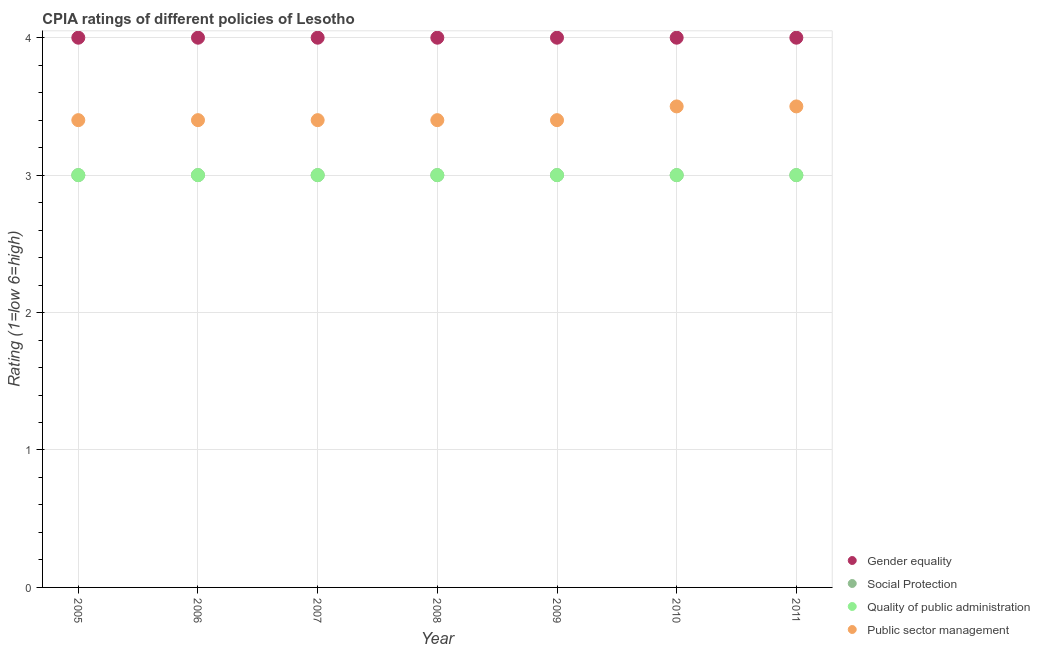Is the number of dotlines equal to the number of legend labels?
Your answer should be compact. Yes. What is the cpia rating of gender equality in 2005?
Provide a succinct answer. 4. Across all years, what is the maximum cpia rating of gender equality?
Provide a short and direct response. 4. Across all years, what is the minimum cpia rating of social protection?
Offer a very short reply. 3. What is the total cpia rating of social protection in the graph?
Offer a very short reply. 21. What is the difference between the cpia rating of social protection in 2011 and the cpia rating of quality of public administration in 2006?
Ensure brevity in your answer.  0. What is the average cpia rating of gender equality per year?
Offer a terse response. 4. What is the ratio of the cpia rating of quality of public administration in 2009 to that in 2010?
Ensure brevity in your answer.  1. Is the cpia rating of public sector management in 2009 less than that in 2010?
Your answer should be compact. Yes. In how many years, is the cpia rating of social protection greater than the average cpia rating of social protection taken over all years?
Give a very brief answer. 0. Is it the case that in every year, the sum of the cpia rating of public sector management and cpia rating of social protection is greater than the sum of cpia rating of gender equality and cpia rating of quality of public administration?
Give a very brief answer. Yes. Is it the case that in every year, the sum of the cpia rating of gender equality and cpia rating of social protection is greater than the cpia rating of quality of public administration?
Offer a terse response. Yes. Is the cpia rating of public sector management strictly less than the cpia rating of gender equality over the years?
Your response must be concise. Yes. How many dotlines are there?
Ensure brevity in your answer.  4. What is the difference between two consecutive major ticks on the Y-axis?
Offer a terse response. 1. Are the values on the major ticks of Y-axis written in scientific E-notation?
Ensure brevity in your answer.  No. Where does the legend appear in the graph?
Ensure brevity in your answer.  Bottom right. How many legend labels are there?
Make the answer very short. 4. What is the title of the graph?
Offer a very short reply. CPIA ratings of different policies of Lesotho. Does "Taxes on revenue" appear as one of the legend labels in the graph?
Your answer should be very brief. No. What is the Rating (1=low 6=high) in Gender equality in 2005?
Give a very brief answer. 4. What is the Rating (1=low 6=high) of Quality of public administration in 2005?
Provide a succinct answer. 3. What is the Rating (1=low 6=high) of Social Protection in 2006?
Offer a very short reply. 3. What is the Rating (1=low 6=high) in Public sector management in 2006?
Offer a terse response. 3.4. What is the Rating (1=low 6=high) in Gender equality in 2007?
Offer a very short reply. 4. What is the Rating (1=low 6=high) in Quality of public administration in 2007?
Your answer should be compact. 3. What is the Rating (1=low 6=high) of Public sector management in 2007?
Your answer should be compact. 3.4. What is the Rating (1=low 6=high) in Gender equality in 2008?
Your answer should be very brief. 4. What is the Rating (1=low 6=high) in Public sector management in 2008?
Your answer should be compact. 3.4. What is the Rating (1=low 6=high) in Gender equality in 2009?
Your answer should be very brief. 4. What is the Rating (1=low 6=high) of Quality of public administration in 2009?
Ensure brevity in your answer.  3. What is the Rating (1=low 6=high) in Social Protection in 2010?
Offer a terse response. 3. What is the Rating (1=low 6=high) in Quality of public administration in 2010?
Your response must be concise. 3. What is the Rating (1=low 6=high) of Quality of public administration in 2011?
Your answer should be very brief. 3. What is the Rating (1=low 6=high) of Public sector management in 2011?
Your response must be concise. 3.5. Across all years, what is the maximum Rating (1=low 6=high) in Quality of public administration?
Offer a terse response. 3. Across all years, what is the minimum Rating (1=low 6=high) of Social Protection?
Provide a short and direct response. 3. Across all years, what is the minimum Rating (1=low 6=high) in Quality of public administration?
Make the answer very short. 3. What is the total Rating (1=low 6=high) of Social Protection in the graph?
Make the answer very short. 21. What is the total Rating (1=low 6=high) of Public sector management in the graph?
Your answer should be compact. 24. What is the difference between the Rating (1=low 6=high) in Social Protection in 2005 and that in 2006?
Keep it short and to the point. 0. What is the difference between the Rating (1=low 6=high) of Public sector management in 2005 and that in 2006?
Ensure brevity in your answer.  0. What is the difference between the Rating (1=low 6=high) of Gender equality in 2005 and that in 2007?
Your answer should be compact. 0. What is the difference between the Rating (1=low 6=high) in Social Protection in 2005 and that in 2007?
Your answer should be very brief. 0. What is the difference between the Rating (1=low 6=high) of Quality of public administration in 2005 and that in 2007?
Make the answer very short. 0. What is the difference between the Rating (1=low 6=high) of Public sector management in 2005 and that in 2007?
Make the answer very short. 0. What is the difference between the Rating (1=low 6=high) in Gender equality in 2005 and that in 2008?
Offer a very short reply. 0. What is the difference between the Rating (1=low 6=high) of Quality of public administration in 2005 and that in 2008?
Offer a terse response. 0. What is the difference between the Rating (1=low 6=high) of Quality of public administration in 2005 and that in 2009?
Give a very brief answer. 0. What is the difference between the Rating (1=low 6=high) in Social Protection in 2005 and that in 2010?
Keep it short and to the point. 0. What is the difference between the Rating (1=low 6=high) in Quality of public administration in 2005 and that in 2010?
Your response must be concise. 0. What is the difference between the Rating (1=low 6=high) of Quality of public administration in 2005 and that in 2011?
Provide a short and direct response. 0. What is the difference between the Rating (1=low 6=high) in Social Protection in 2006 and that in 2008?
Your response must be concise. 0. What is the difference between the Rating (1=low 6=high) of Social Protection in 2006 and that in 2009?
Offer a very short reply. 0. What is the difference between the Rating (1=low 6=high) in Public sector management in 2006 and that in 2009?
Offer a very short reply. 0. What is the difference between the Rating (1=low 6=high) in Gender equality in 2006 and that in 2010?
Provide a short and direct response. 0. What is the difference between the Rating (1=low 6=high) of Public sector management in 2006 and that in 2010?
Your response must be concise. -0.1. What is the difference between the Rating (1=low 6=high) of Social Protection in 2007 and that in 2008?
Offer a terse response. 0. What is the difference between the Rating (1=low 6=high) in Quality of public administration in 2007 and that in 2008?
Your answer should be compact. 0. What is the difference between the Rating (1=low 6=high) of Public sector management in 2007 and that in 2008?
Offer a very short reply. 0. What is the difference between the Rating (1=low 6=high) of Gender equality in 2007 and that in 2009?
Give a very brief answer. 0. What is the difference between the Rating (1=low 6=high) in Public sector management in 2007 and that in 2009?
Ensure brevity in your answer.  0. What is the difference between the Rating (1=low 6=high) of Gender equality in 2007 and that in 2010?
Offer a very short reply. 0. What is the difference between the Rating (1=low 6=high) of Quality of public administration in 2007 and that in 2010?
Your answer should be very brief. 0. What is the difference between the Rating (1=low 6=high) in Gender equality in 2007 and that in 2011?
Your answer should be very brief. 0. What is the difference between the Rating (1=low 6=high) in Quality of public administration in 2007 and that in 2011?
Ensure brevity in your answer.  0. What is the difference between the Rating (1=low 6=high) of Social Protection in 2008 and that in 2009?
Ensure brevity in your answer.  0. What is the difference between the Rating (1=low 6=high) of Quality of public administration in 2008 and that in 2009?
Your answer should be compact. 0. What is the difference between the Rating (1=low 6=high) in Public sector management in 2008 and that in 2009?
Your answer should be compact. 0. What is the difference between the Rating (1=low 6=high) of Gender equality in 2008 and that in 2010?
Give a very brief answer. 0. What is the difference between the Rating (1=low 6=high) in Quality of public administration in 2008 and that in 2010?
Your response must be concise. 0. What is the difference between the Rating (1=low 6=high) of Public sector management in 2008 and that in 2010?
Give a very brief answer. -0.1. What is the difference between the Rating (1=low 6=high) in Gender equality in 2008 and that in 2011?
Give a very brief answer. 0. What is the difference between the Rating (1=low 6=high) of Quality of public administration in 2008 and that in 2011?
Make the answer very short. 0. What is the difference between the Rating (1=low 6=high) in Public sector management in 2008 and that in 2011?
Offer a very short reply. -0.1. What is the difference between the Rating (1=low 6=high) of Gender equality in 2009 and that in 2010?
Ensure brevity in your answer.  0. What is the difference between the Rating (1=low 6=high) of Social Protection in 2009 and that in 2010?
Give a very brief answer. 0. What is the difference between the Rating (1=low 6=high) in Gender equality in 2009 and that in 2011?
Keep it short and to the point. 0. What is the difference between the Rating (1=low 6=high) of Quality of public administration in 2009 and that in 2011?
Offer a terse response. 0. What is the difference between the Rating (1=low 6=high) in Gender equality in 2010 and that in 2011?
Ensure brevity in your answer.  0. What is the difference between the Rating (1=low 6=high) in Quality of public administration in 2010 and that in 2011?
Offer a terse response. 0. What is the difference between the Rating (1=low 6=high) of Gender equality in 2005 and the Rating (1=low 6=high) of Public sector management in 2006?
Your answer should be very brief. 0.6. What is the difference between the Rating (1=low 6=high) of Social Protection in 2005 and the Rating (1=low 6=high) of Public sector management in 2006?
Give a very brief answer. -0.4. What is the difference between the Rating (1=low 6=high) of Quality of public administration in 2005 and the Rating (1=low 6=high) of Public sector management in 2006?
Provide a short and direct response. -0.4. What is the difference between the Rating (1=low 6=high) of Social Protection in 2005 and the Rating (1=low 6=high) of Quality of public administration in 2007?
Provide a succinct answer. 0. What is the difference between the Rating (1=low 6=high) of Social Protection in 2005 and the Rating (1=low 6=high) of Public sector management in 2007?
Your answer should be compact. -0.4. What is the difference between the Rating (1=low 6=high) of Quality of public administration in 2005 and the Rating (1=low 6=high) of Public sector management in 2007?
Your answer should be very brief. -0.4. What is the difference between the Rating (1=low 6=high) in Gender equality in 2005 and the Rating (1=low 6=high) in Social Protection in 2008?
Make the answer very short. 1. What is the difference between the Rating (1=low 6=high) of Gender equality in 2005 and the Rating (1=low 6=high) of Quality of public administration in 2008?
Keep it short and to the point. 1. What is the difference between the Rating (1=low 6=high) of Gender equality in 2005 and the Rating (1=low 6=high) of Public sector management in 2008?
Provide a short and direct response. 0.6. What is the difference between the Rating (1=low 6=high) of Social Protection in 2005 and the Rating (1=low 6=high) of Quality of public administration in 2008?
Keep it short and to the point. 0. What is the difference between the Rating (1=low 6=high) in Gender equality in 2005 and the Rating (1=low 6=high) in Quality of public administration in 2009?
Make the answer very short. 1. What is the difference between the Rating (1=low 6=high) of Social Protection in 2005 and the Rating (1=low 6=high) of Quality of public administration in 2009?
Provide a succinct answer. 0. What is the difference between the Rating (1=low 6=high) in Social Protection in 2005 and the Rating (1=low 6=high) in Public sector management in 2009?
Your answer should be compact. -0.4. What is the difference between the Rating (1=low 6=high) in Gender equality in 2005 and the Rating (1=low 6=high) in Quality of public administration in 2010?
Ensure brevity in your answer.  1. What is the difference between the Rating (1=low 6=high) of Gender equality in 2005 and the Rating (1=low 6=high) of Public sector management in 2010?
Offer a very short reply. 0.5. What is the difference between the Rating (1=low 6=high) of Social Protection in 2005 and the Rating (1=low 6=high) of Quality of public administration in 2010?
Your answer should be very brief. 0. What is the difference between the Rating (1=low 6=high) in Social Protection in 2005 and the Rating (1=low 6=high) in Public sector management in 2010?
Provide a succinct answer. -0.5. What is the difference between the Rating (1=low 6=high) of Quality of public administration in 2005 and the Rating (1=low 6=high) of Public sector management in 2010?
Your response must be concise. -0.5. What is the difference between the Rating (1=low 6=high) in Gender equality in 2005 and the Rating (1=low 6=high) in Public sector management in 2011?
Keep it short and to the point. 0.5. What is the difference between the Rating (1=low 6=high) of Social Protection in 2005 and the Rating (1=low 6=high) of Quality of public administration in 2011?
Offer a very short reply. 0. What is the difference between the Rating (1=low 6=high) in Gender equality in 2006 and the Rating (1=low 6=high) in Quality of public administration in 2007?
Offer a terse response. 1. What is the difference between the Rating (1=low 6=high) of Social Protection in 2006 and the Rating (1=low 6=high) of Quality of public administration in 2007?
Provide a succinct answer. 0. What is the difference between the Rating (1=low 6=high) in Quality of public administration in 2006 and the Rating (1=low 6=high) in Public sector management in 2007?
Offer a terse response. -0.4. What is the difference between the Rating (1=low 6=high) of Gender equality in 2006 and the Rating (1=low 6=high) of Social Protection in 2008?
Offer a very short reply. 1. What is the difference between the Rating (1=low 6=high) in Gender equality in 2006 and the Rating (1=low 6=high) in Quality of public administration in 2008?
Make the answer very short. 1. What is the difference between the Rating (1=low 6=high) of Gender equality in 2006 and the Rating (1=low 6=high) of Public sector management in 2008?
Give a very brief answer. 0.6. What is the difference between the Rating (1=low 6=high) in Social Protection in 2006 and the Rating (1=low 6=high) in Public sector management in 2008?
Provide a short and direct response. -0.4. What is the difference between the Rating (1=low 6=high) of Quality of public administration in 2006 and the Rating (1=low 6=high) of Public sector management in 2008?
Make the answer very short. -0.4. What is the difference between the Rating (1=low 6=high) in Gender equality in 2006 and the Rating (1=low 6=high) in Social Protection in 2009?
Your response must be concise. 1. What is the difference between the Rating (1=low 6=high) of Gender equality in 2006 and the Rating (1=low 6=high) of Quality of public administration in 2009?
Provide a short and direct response. 1. What is the difference between the Rating (1=low 6=high) in Gender equality in 2006 and the Rating (1=low 6=high) in Public sector management in 2009?
Provide a succinct answer. 0.6. What is the difference between the Rating (1=low 6=high) of Social Protection in 2006 and the Rating (1=low 6=high) of Quality of public administration in 2009?
Offer a terse response. 0. What is the difference between the Rating (1=low 6=high) of Gender equality in 2006 and the Rating (1=low 6=high) of Public sector management in 2010?
Your answer should be compact. 0.5. What is the difference between the Rating (1=low 6=high) of Social Protection in 2006 and the Rating (1=low 6=high) of Public sector management in 2010?
Make the answer very short. -0.5. What is the difference between the Rating (1=low 6=high) of Gender equality in 2006 and the Rating (1=low 6=high) of Social Protection in 2011?
Keep it short and to the point. 1. What is the difference between the Rating (1=low 6=high) in Gender equality in 2006 and the Rating (1=low 6=high) in Quality of public administration in 2011?
Keep it short and to the point. 1. What is the difference between the Rating (1=low 6=high) in Social Protection in 2006 and the Rating (1=low 6=high) in Quality of public administration in 2011?
Give a very brief answer. 0. What is the difference between the Rating (1=low 6=high) in Quality of public administration in 2006 and the Rating (1=low 6=high) in Public sector management in 2011?
Provide a short and direct response. -0.5. What is the difference between the Rating (1=low 6=high) in Gender equality in 2007 and the Rating (1=low 6=high) in Social Protection in 2008?
Offer a very short reply. 1. What is the difference between the Rating (1=low 6=high) in Gender equality in 2007 and the Rating (1=low 6=high) in Public sector management in 2008?
Your answer should be very brief. 0.6. What is the difference between the Rating (1=low 6=high) in Gender equality in 2007 and the Rating (1=low 6=high) in Quality of public administration in 2009?
Make the answer very short. 1. What is the difference between the Rating (1=low 6=high) of Social Protection in 2007 and the Rating (1=low 6=high) of Quality of public administration in 2009?
Offer a very short reply. 0. What is the difference between the Rating (1=low 6=high) of Social Protection in 2007 and the Rating (1=low 6=high) of Public sector management in 2009?
Offer a very short reply. -0.4. What is the difference between the Rating (1=low 6=high) of Gender equality in 2007 and the Rating (1=low 6=high) of Social Protection in 2010?
Offer a terse response. 1. What is the difference between the Rating (1=low 6=high) in Gender equality in 2007 and the Rating (1=low 6=high) in Quality of public administration in 2010?
Your answer should be very brief. 1. What is the difference between the Rating (1=low 6=high) in Gender equality in 2007 and the Rating (1=low 6=high) in Public sector management in 2010?
Make the answer very short. 0.5. What is the difference between the Rating (1=low 6=high) of Social Protection in 2007 and the Rating (1=low 6=high) of Quality of public administration in 2010?
Provide a succinct answer. 0. What is the difference between the Rating (1=low 6=high) of Gender equality in 2007 and the Rating (1=low 6=high) of Quality of public administration in 2011?
Keep it short and to the point. 1. What is the difference between the Rating (1=low 6=high) of Social Protection in 2007 and the Rating (1=low 6=high) of Quality of public administration in 2011?
Provide a short and direct response. 0. What is the difference between the Rating (1=low 6=high) of Gender equality in 2008 and the Rating (1=low 6=high) of Quality of public administration in 2009?
Provide a short and direct response. 1. What is the difference between the Rating (1=low 6=high) in Gender equality in 2008 and the Rating (1=low 6=high) in Quality of public administration in 2010?
Offer a terse response. 1. What is the difference between the Rating (1=low 6=high) in Gender equality in 2008 and the Rating (1=low 6=high) in Public sector management in 2010?
Keep it short and to the point. 0.5. What is the difference between the Rating (1=low 6=high) in Social Protection in 2008 and the Rating (1=low 6=high) in Quality of public administration in 2010?
Provide a succinct answer. 0. What is the difference between the Rating (1=low 6=high) in Social Protection in 2008 and the Rating (1=low 6=high) in Public sector management in 2010?
Your answer should be very brief. -0.5. What is the difference between the Rating (1=low 6=high) in Quality of public administration in 2008 and the Rating (1=low 6=high) in Public sector management in 2010?
Ensure brevity in your answer.  -0.5. What is the difference between the Rating (1=low 6=high) of Gender equality in 2008 and the Rating (1=low 6=high) of Public sector management in 2011?
Offer a terse response. 0.5. What is the difference between the Rating (1=low 6=high) in Quality of public administration in 2008 and the Rating (1=low 6=high) in Public sector management in 2011?
Keep it short and to the point. -0.5. What is the difference between the Rating (1=low 6=high) in Gender equality in 2009 and the Rating (1=low 6=high) in Quality of public administration in 2010?
Your answer should be compact. 1. What is the difference between the Rating (1=low 6=high) in Social Protection in 2009 and the Rating (1=low 6=high) in Quality of public administration in 2010?
Provide a succinct answer. 0. What is the difference between the Rating (1=low 6=high) in Quality of public administration in 2009 and the Rating (1=low 6=high) in Public sector management in 2010?
Ensure brevity in your answer.  -0.5. What is the difference between the Rating (1=low 6=high) in Gender equality in 2009 and the Rating (1=low 6=high) in Social Protection in 2011?
Provide a short and direct response. 1. What is the difference between the Rating (1=low 6=high) of Gender equality in 2009 and the Rating (1=low 6=high) of Public sector management in 2011?
Give a very brief answer. 0.5. What is the difference between the Rating (1=low 6=high) in Social Protection in 2009 and the Rating (1=low 6=high) in Quality of public administration in 2011?
Give a very brief answer. 0. What is the difference between the Rating (1=low 6=high) of Social Protection in 2009 and the Rating (1=low 6=high) of Public sector management in 2011?
Offer a terse response. -0.5. What is the difference between the Rating (1=low 6=high) of Gender equality in 2010 and the Rating (1=low 6=high) of Public sector management in 2011?
Offer a terse response. 0.5. What is the difference between the Rating (1=low 6=high) of Social Protection in 2010 and the Rating (1=low 6=high) of Quality of public administration in 2011?
Make the answer very short. 0. What is the average Rating (1=low 6=high) in Gender equality per year?
Offer a very short reply. 4. What is the average Rating (1=low 6=high) in Social Protection per year?
Your answer should be very brief. 3. What is the average Rating (1=low 6=high) in Quality of public administration per year?
Keep it short and to the point. 3. What is the average Rating (1=low 6=high) in Public sector management per year?
Your answer should be compact. 3.43. In the year 2005, what is the difference between the Rating (1=low 6=high) in Gender equality and Rating (1=low 6=high) in Social Protection?
Offer a very short reply. 1. In the year 2006, what is the difference between the Rating (1=low 6=high) of Gender equality and Rating (1=low 6=high) of Quality of public administration?
Provide a succinct answer. 1. In the year 2006, what is the difference between the Rating (1=low 6=high) in Gender equality and Rating (1=low 6=high) in Public sector management?
Keep it short and to the point. 0.6. In the year 2006, what is the difference between the Rating (1=low 6=high) of Social Protection and Rating (1=low 6=high) of Quality of public administration?
Provide a succinct answer. 0. In the year 2006, what is the difference between the Rating (1=low 6=high) of Social Protection and Rating (1=low 6=high) of Public sector management?
Provide a short and direct response. -0.4. In the year 2008, what is the difference between the Rating (1=low 6=high) in Gender equality and Rating (1=low 6=high) in Social Protection?
Give a very brief answer. 1. In the year 2008, what is the difference between the Rating (1=low 6=high) in Gender equality and Rating (1=low 6=high) in Quality of public administration?
Provide a short and direct response. 1. In the year 2008, what is the difference between the Rating (1=low 6=high) of Social Protection and Rating (1=low 6=high) of Public sector management?
Ensure brevity in your answer.  -0.4. In the year 2008, what is the difference between the Rating (1=low 6=high) in Quality of public administration and Rating (1=low 6=high) in Public sector management?
Provide a short and direct response. -0.4. In the year 2009, what is the difference between the Rating (1=low 6=high) of Gender equality and Rating (1=low 6=high) of Social Protection?
Give a very brief answer. 1. In the year 2009, what is the difference between the Rating (1=low 6=high) in Gender equality and Rating (1=low 6=high) in Quality of public administration?
Offer a very short reply. 1. In the year 2009, what is the difference between the Rating (1=low 6=high) of Gender equality and Rating (1=low 6=high) of Public sector management?
Your response must be concise. 0.6. In the year 2009, what is the difference between the Rating (1=low 6=high) in Social Protection and Rating (1=low 6=high) in Public sector management?
Give a very brief answer. -0.4. In the year 2010, what is the difference between the Rating (1=low 6=high) in Gender equality and Rating (1=low 6=high) in Quality of public administration?
Keep it short and to the point. 1. In the year 2010, what is the difference between the Rating (1=low 6=high) in Social Protection and Rating (1=low 6=high) in Quality of public administration?
Offer a very short reply. 0. In the year 2010, what is the difference between the Rating (1=low 6=high) in Quality of public administration and Rating (1=low 6=high) in Public sector management?
Your response must be concise. -0.5. In the year 2011, what is the difference between the Rating (1=low 6=high) of Gender equality and Rating (1=low 6=high) of Public sector management?
Provide a succinct answer. 0.5. In the year 2011, what is the difference between the Rating (1=low 6=high) of Social Protection and Rating (1=low 6=high) of Quality of public administration?
Your response must be concise. 0. In the year 2011, what is the difference between the Rating (1=low 6=high) in Quality of public administration and Rating (1=low 6=high) in Public sector management?
Your response must be concise. -0.5. What is the ratio of the Rating (1=low 6=high) of Social Protection in 2005 to that in 2006?
Provide a short and direct response. 1. What is the ratio of the Rating (1=low 6=high) in Gender equality in 2005 to that in 2007?
Give a very brief answer. 1. What is the ratio of the Rating (1=low 6=high) of Gender equality in 2005 to that in 2008?
Offer a very short reply. 1. What is the ratio of the Rating (1=low 6=high) in Social Protection in 2005 to that in 2008?
Ensure brevity in your answer.  1. What is the ratio of the Rating (1=low 6=high) in Quality of public administration in 2005 to that in 2008?
Ensure brevity in your answer.  1. What is the ratio of the Rating (1=low 6=high) of Social Protection in 2005 to that in 2009?
Offer a very short reply. 1. What is the ratio of the Rating (1=low 6=high) in Quality of public administration in 2005 to that in 2009?
Give a very brief answer. 1. What is the ratio of the Rating (1=low 6=high) in Quality of public administration in 2005 to that in 2010?
Ensure brevity in your answer.  1. What is the ratio of the Rating (1=low 6=high) of Public sector management in 2005 to that in 2010?
Your response must be concise. 0.97. What is the ratio of the Rating (1=low 6=high) of Gender equality in 2005 to that in 2011?
Offer a very short reply. 1. What is the ratio of the Rating (1=low 6=high) of Public sector management in 2005 to that in 2011?
Offer a very short reply. 0.97. What is the ratio of the Rating (1=low 6=high) of Social Protection in 2006 to that in 2007?
Your answer should be compact. 1. What is the ratio of the Rating (1=low 6=high) of Social Protection in 2006 to that in 2008?
Keep it short and to the point. 1. What is the ratio of the Rating (1=low 6=high) of Quality of public administration in 2006 to that in 2008?
Provide a short and direct response. 1. What is the ratio of the Rating (1=low 6=high) of Public sector management in 2006 to that in 2008?
Keep it short and to the point. 1. What is the ratio of the Rating (1=low 6=high) in Social Protection in 2006 to that in 2009?
Keep it short and to the point. 1. What is the ratio of the Rating (1=low 6=high) in Quality of public administration in 2006 to that in 2009?
Offer a terse response. 1. What is the ratio of the Rating (1=low 6=high) in Gender equality in 2006 to that in 2010?
Make the answer very short. 1. What is the ratio of the Rating (1=low 6=high) of Public sector management in 2006 to that in 2010?
Give a very brief answer. 0.97. What is the ratio of the Rating (1=low 6=high) of Gender equality in 2006 to that in 2011?
Offer a terse response. 1. What is the ratio of the Rating (1=low 6=high) in Public sector management in 2006 to that in 2011?
Your answer should be very brief. 0.97. What is the ratio of the Rating (1=low 6=high) in Gender equality in 2007 to that in 2008?
Provide a succinct answer. 1. What is the ratio of the Rating (1=low 6=high) in Public sector management in 2007 to that in 2008?
Provide a succinct answer. 1. What is the ratio of the Rating (1=low 6=high) in Gender equality in 2007 to that in 2009?
Provide a short and direct response. 1. What is the ratio of the Rating (1=low 6=high) of Quality of public administration in 2007 to that in 2009?
Provide a succinct answer. 1. What is the ratio of the Rating (1=low 6=high) of Gender equality in 2007 to that in 2010?
Provide a short and direct response. 1. What is the ratio of the Rating (1=low 6=high) of Quality of public administration in 2007 to that in 2010?
Offer a very short reply. 1. What is the ratio of the Rating (1=low 6=high) in Public sector management in 2007 to that in 2010?
Keep it short and to the point. 0.97. What is the ratio of the Rating (1=low 6=high) of Gender equality in 2007 to that in 2011?
Give a very brief answer. 1. What is the ratio of the Rating (1=low 6=high) in Social Protection in 2007 to that in 2011?
Give a very brief answer. 1. What is the ratio of the Rating (1=low 6=high) in Public sector management in 2007 to that in 2011?
Provide a succinct answer. 0.97. What is the ratio of the Rating (1=low 6=high) of Public sector management in 2008 to that in 2009?
Give a very brief answer. 1. What is the ratio of the Rating (1=low 6=high) of Social Protection in 2008 to that in 2010?
Offer a very short reply. 1. What is the ratio of the Rating (1=low 6=high) of Quality of public administration in 2008 to that in 2010?
Offer a terse response. 1. What is the ratio of the Rating (1=low 6=high) of Public sector management in 2008 to that in 2010?
Offer a very short reply. 0.97. What is the ratio of the Rating (1=low 6=high) of Social Protection in 2008 to that in 2011?
Your response must be concise. 1. What is the ratio of the Rating (1=low 6=high) in Quality of public administration in 2008 to that in 2011?
Give a very brief answer. 1. What is the ratio of the Rating (1=low 6=high) in Public sector management in 2008 to that in 2011?
Provide a succinct answer. 0.97. What is the ratio of the Rating (1=low 6=high) in Social Protection in 2009 to that in 2010?
Keep it short and to the point. 1. What is the ratio of the Rating (1=low 6=high) in Quality of public administration in 2009 to that in 2010?
Keep it short and to the point. 1. What is the ratio of the Rating (1=low 6=high) of Public sector management in 2009 to that in 2010?
Make the answer very short. 0.97. What is the ratio of the Rating (1=low 6=high) of Gender equality in 2009 to that in 2011?
Ensure brevity in your answer.  1. What is the ratio of the Rating (1=low 6=high) in Quality of public administration in 2009 to that in 2011?
Provide a short and direct response. 1. What is the ratio of the Rating (1=low 6=high) of Public sector management in 2009 to that in 2011?
Provide a succinct answer. 0.97. What is the difference between the highest and the lowest Rating (1=low 6=high) of Gender equality?
Offer a terse response. 0. What is the difference between the highest and the lowest Rating (1=low 6=high) of Social Protection?
Give a very brief answer. 0. What is the difference between the highest and the lowest Rating (1=low 6=high) in Public sector management?
Make the answer very short. 0.1. 